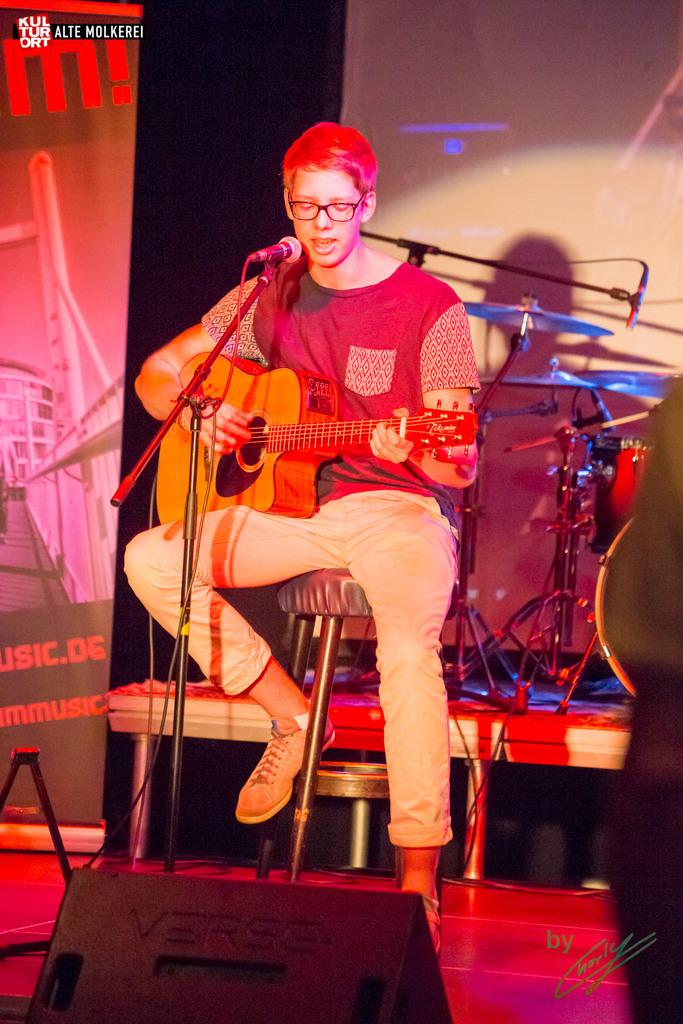What is the main subject of the image? The main subject of the image is a man. What is the man doing in the image? The man is sitting on a stool, playing the guitar, and singing. What rule is the man following while playing the guitar in the image? There is no specific rule mentioned in the image, and the man is simply playing the guitar. Is there a box visible in the image? No, there is no box present in the image. 